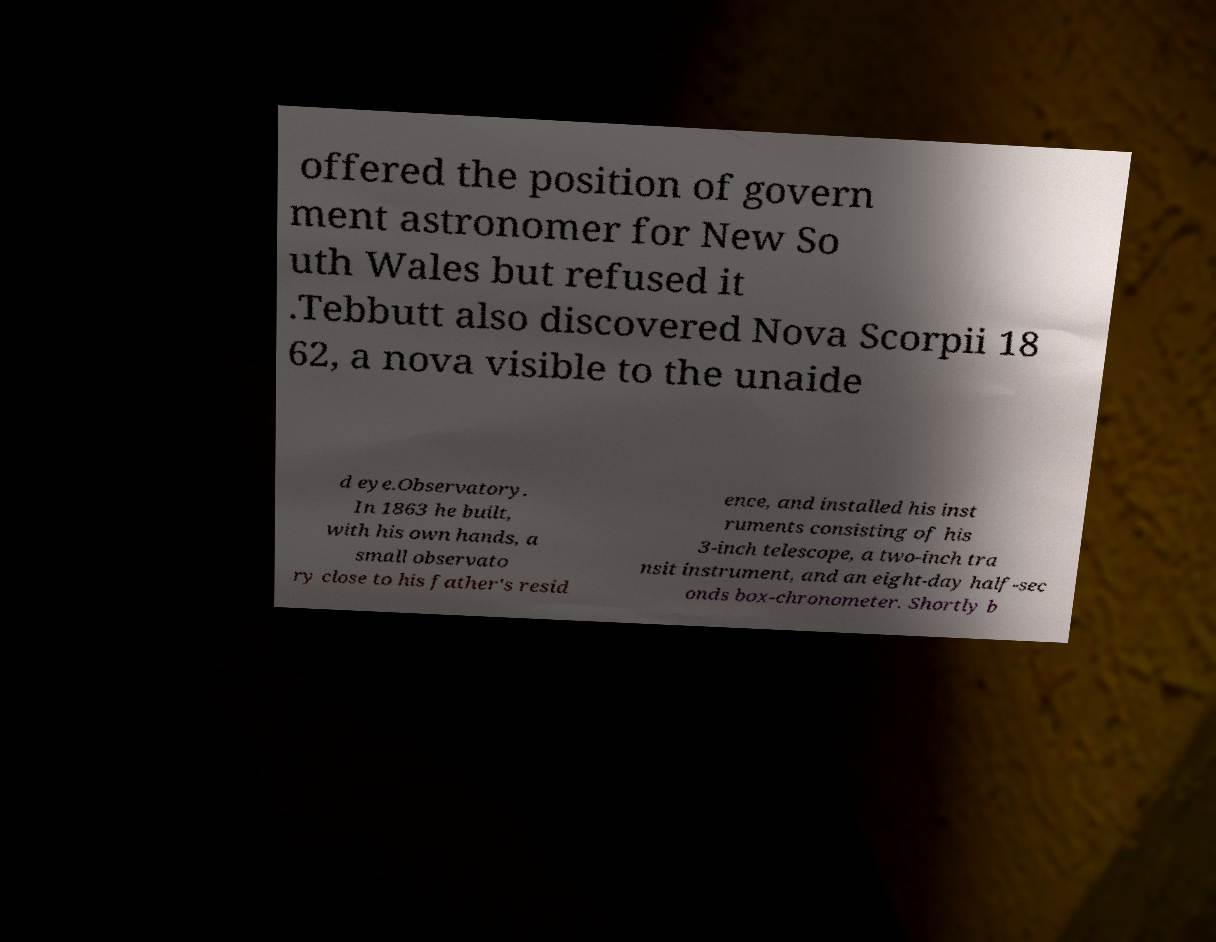Can you read and provide the text displayed in the image?This photo seems to have some interesting text. Can you extract and type it out for me? offered the position of govern ment astronomer for New So uth Wales but refused it .Tebbutt also discovered Nova Scorpii 18 62, a nova visible to the unaide d eye.Observatory. In 1863 he built, with his own hands, a small observato ry close to his father's resid ence, and installed his inst ruments consisting of his 3-inch telescope, a two-inch tra nsit instrument, and an eight-day half-sec onds box-chronometer. Shortly b 